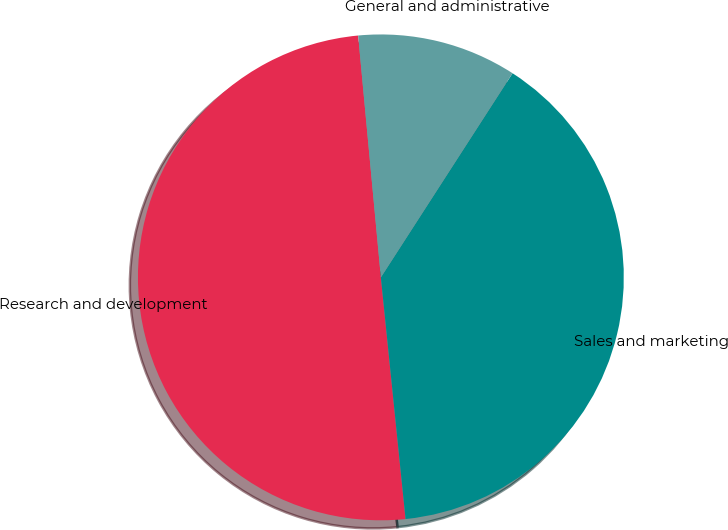Convert chart. <chart><loc_0><loc_0><loc_500><loc_500><pie_chart><fcel>Research and development<fcel>Sales and marketing<fcel>General and administrative<nl><fcel>50.13%<fcel>39.26%<fcel>10.61%<nl></chart> 